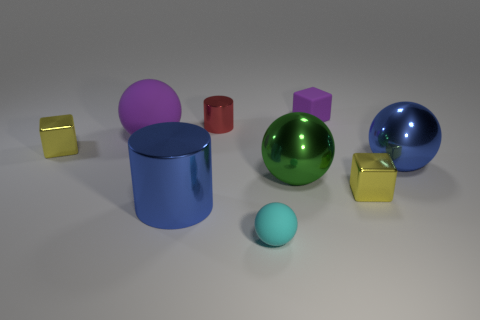What number of purple objects are big rubber balls or tiny matte things?
Offer a very short reply. 2. Are there more red objects than large yellow rubber blocks?
Offer a very short reply. Yes. There is a rubber block that is the same size as the cyan ball; what is its color?
Your answer should be very brief. Purple. What number of blocks are large green metallic objects or purple things?
Make the answer very short. 1. Does the big purple matte object have the same shape as the thing that is in front of the large blue cylinder?
Your response must be concise. Yes. How many red matte cubes are the same size as the green thing?
Your answer should be very brief. 0. Does the metal object that is on the left side of the purple ball have the same shape as the matte thing in front of the blue shiny ball?
Give a very brief answer. No. There is a rubber object that is the same color as the matte cube; what is its shape?
Keep it short and to the point. Sphere. What color is the metallic sphere that is to the left of the ball right of the rubber cube?
Keep it short and to the point. Green. What is the color of the tiny object that is the same shape as the large purple thing?
Your answer should be compact. Cyan. 